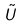<formula> <loc_0><loc_0><loc_500><loc_500>\tilde { U }</formula> 